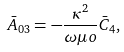Convert formula to latex. <formula><loc_0><loc_0><loc_500><loc_500>\bar { A } _ { 0 3 } = - \frac { \kappa ^ { 2 } } { \omega \mu o } \bar { C } _ { 4 } ,</formula> 